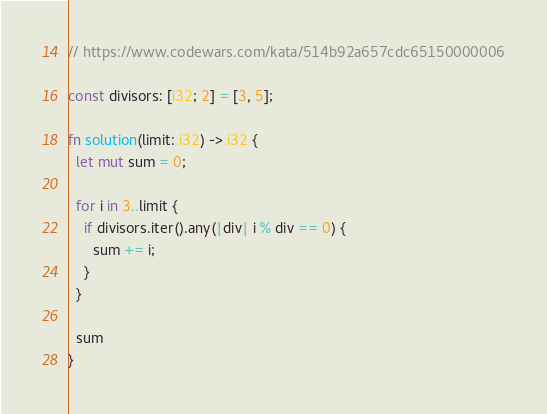Convert code to text. <code><loc_0><loc_0><loc_500><loc_500><_Rust_>// https://www.codewars.com/kata/514b92a657cdc65150000006

const divisors: [i32; 2] = [3, 5];

fn solution(limit: i32) -> i32 {
  let mut sum = 0;

  for i in 3..limit {
    if divisors.iter().any(|div| i % div == 0) {
      sum += i;
    }
  }

  sum
}

</code> 